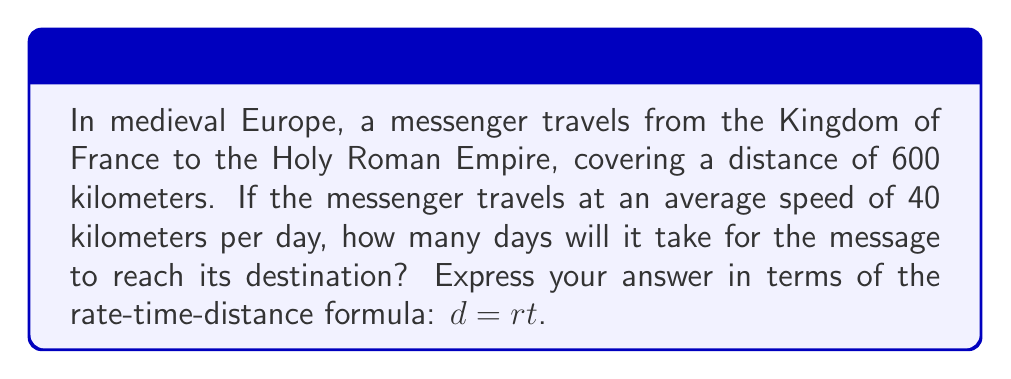Can you solve this math problem? To solve this problem, we'll use the rate-time-distance formula: $d = rt$, where:
$d$ = distance
$r$ = rate (speed)
$t$ = time

We're given:
$d = 600$ kilometers
$r = 40$ kilometers per day

We need to solve for $t$ (time in days).

Step 1: Rearrange the formula to solve for $t$:
$$t = \frac{d}{r}$$

Step 2: Substitute the known values:
$$t = \frac{600 \text{ km}}{40 \text{ km/day}}$$

Step 3: Cancel out units and calculate:
$$t = \frac{600}{40} \text{ days} = 15 \text{ days}$$

Therefore, it will take the messenger 15 days to travel from the Kingdom of France to the Holy Roman Empire.
Answer: 15 days 